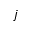Convert formula to latex. <formula><loc_0><loc_0><loc_500><loc_500>j</formula> 